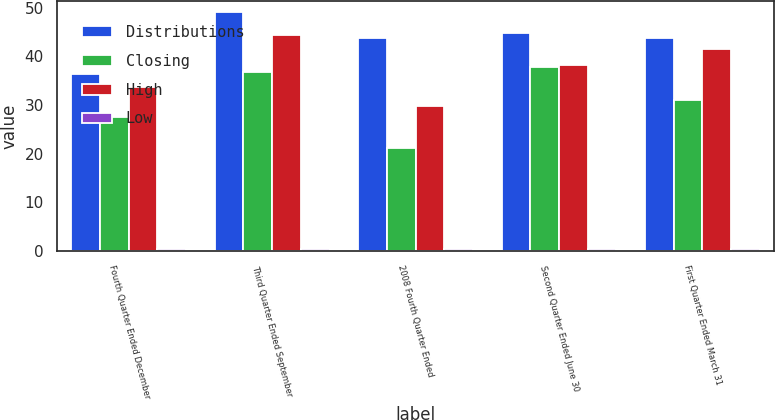Convert chart to OTSL. <chart><loc_0><loc_0><loc_500><loc_500><stacked_bar_chart><ecel><fcel>Fourth Quarter Ended December<fcel>Third Quarter Ended September<fcel>2008 Fourth Quarter Ended<fcel>Second Quarter Ended June 30<fcel>First Quarter Ended March 31<nl><fcel>Distributions<fcel>36.38<fcel>49<fcel>43.76<fcel>44.89<fcel>43.78<nl><fcel>Closing<fcel>27.54<fcel>36.84<fcel>21.27<fcel>37.76<fcel>31.07<nl><fcel>High<fcel>33.78<fcel>44.41<fcel>29.82<fcel>38.27<fcel>41.49<nl><fcel>Low<fcel>0.34<fcel>0.48<fcel>0.48<fcel>0.48<fcel>0.48<nl></chart> 